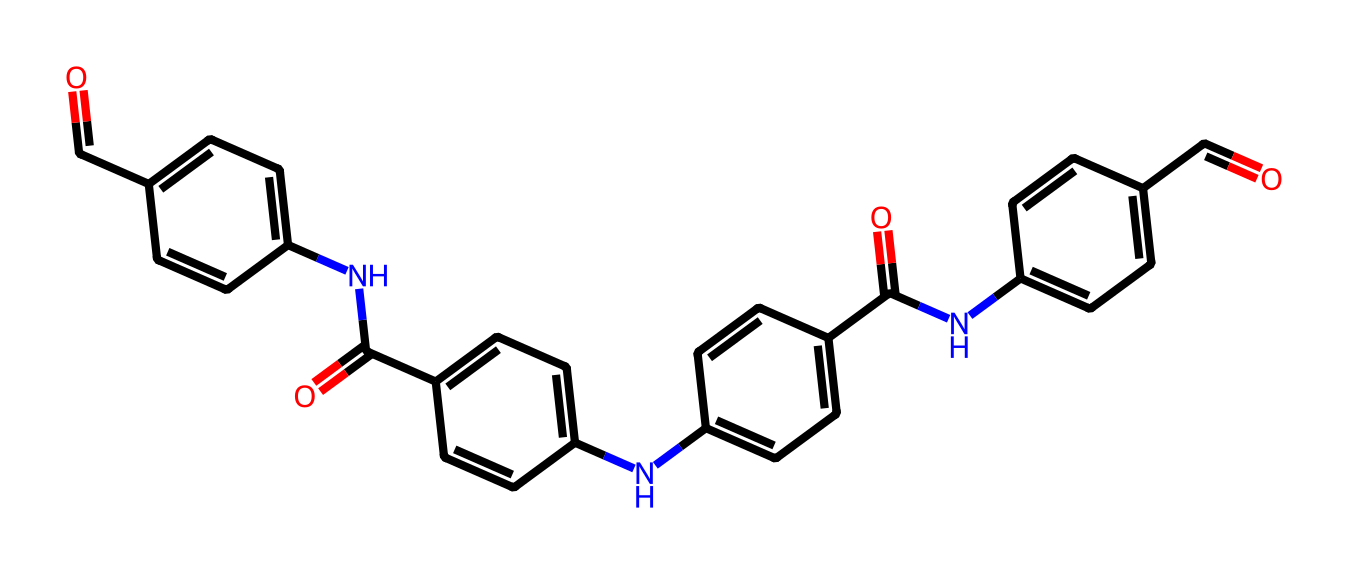What is the main functional group present in this compound? The compound contains multiple carbonyl groups (C=O) linked to each aromatic ring, which are characteristic of amides.
Answer: amide How many aromatic rings are present in this structure? By analyzing the structure, there are four distinct aromatic rings (indicated as 'c' in the SMILES representation) connected by amide linkages.
Answer: four What kind of bonds connect the atoms in this chemical? The atoms in this compound are primarily connected by covalent bonds, which include single bonds (C-C) and double bonds (C=O) that connect the carbonyl groups.
Answer: covalent bonds What type of polymer could this structure represent? Due to its amide functional groups and aromatic rings, this structure likely represents a type of aramid fiber, known for its strength and heat resistance.
Answer: aramid fiber Why does the arrangement of the compound contribute to its strength? The rigid aromatic rings provide tensile strength and stability, while the hydrogen bonding between amide groups contributes to the overall structural integrity, leading to enhanced mechanical properties.
Answer: tensile strength 